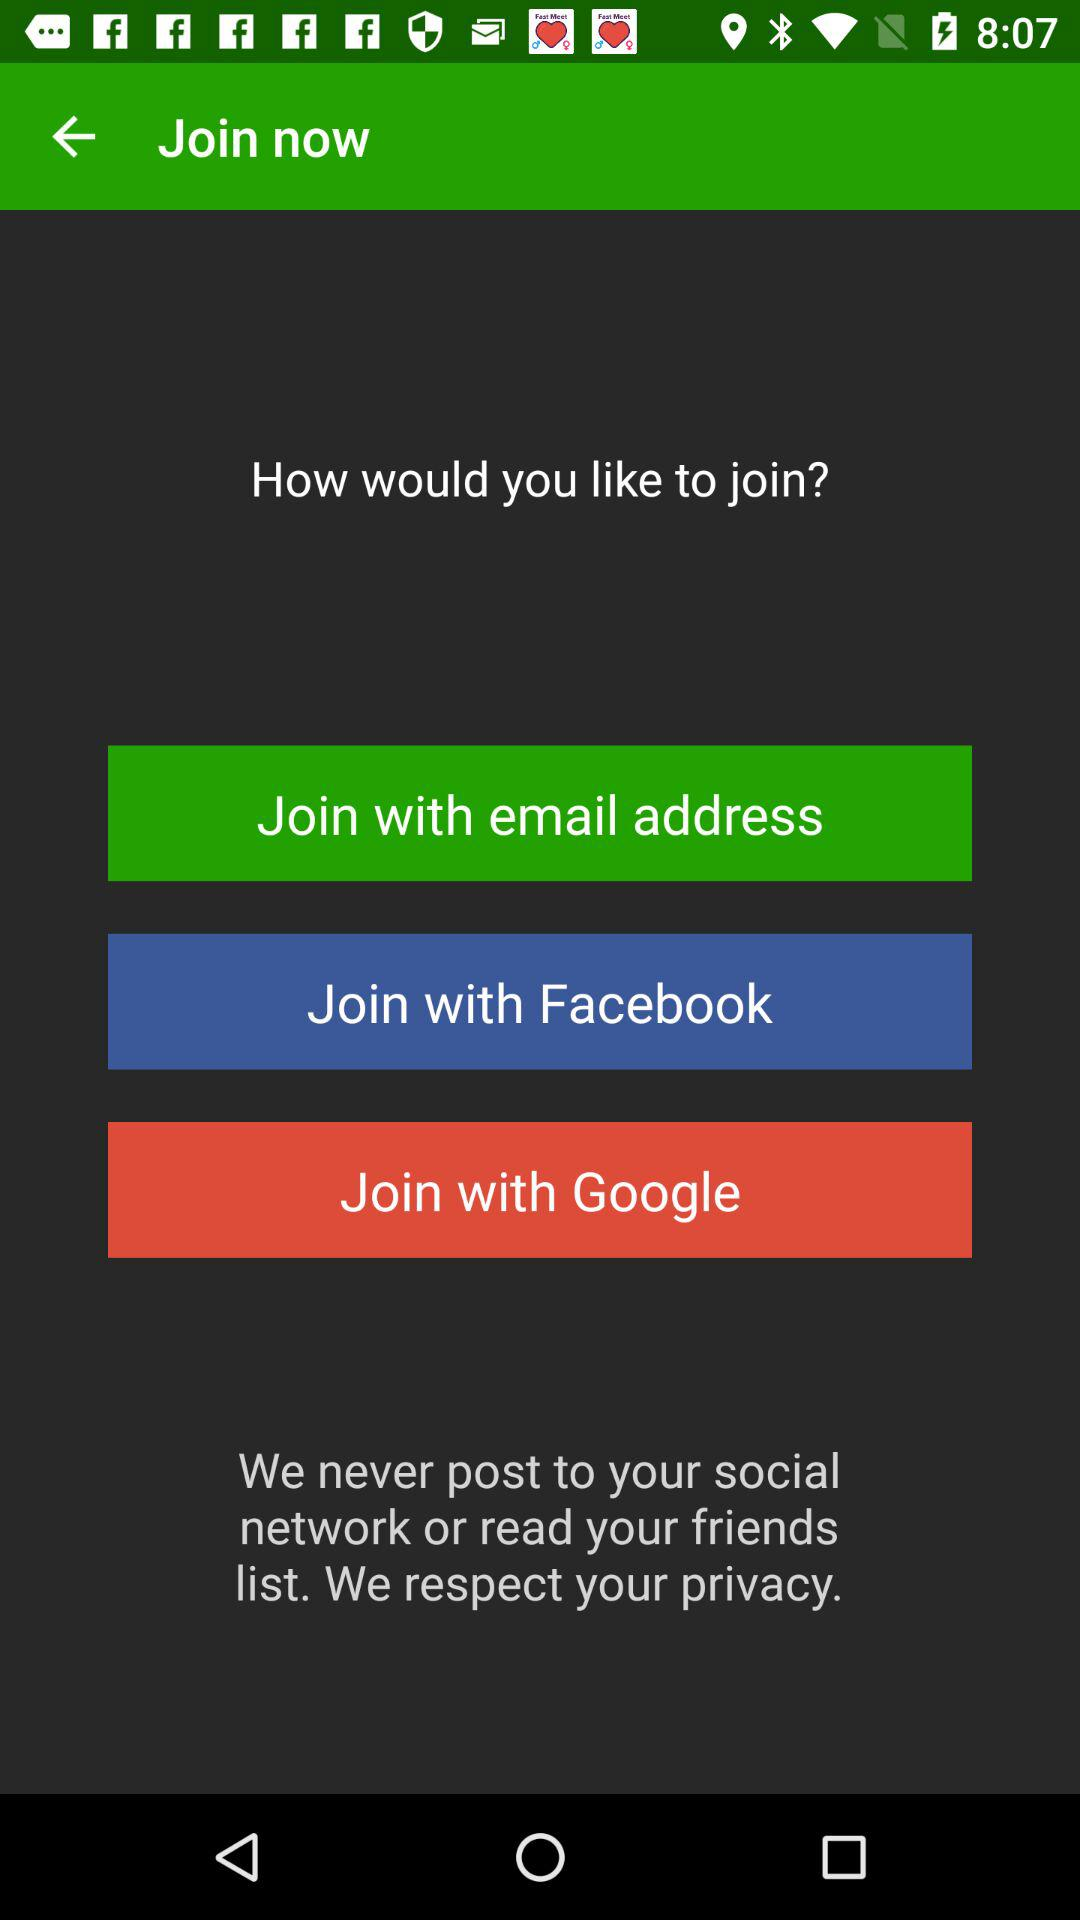How many ways are there to join?
Answer the question using a single word or phrase. 3 